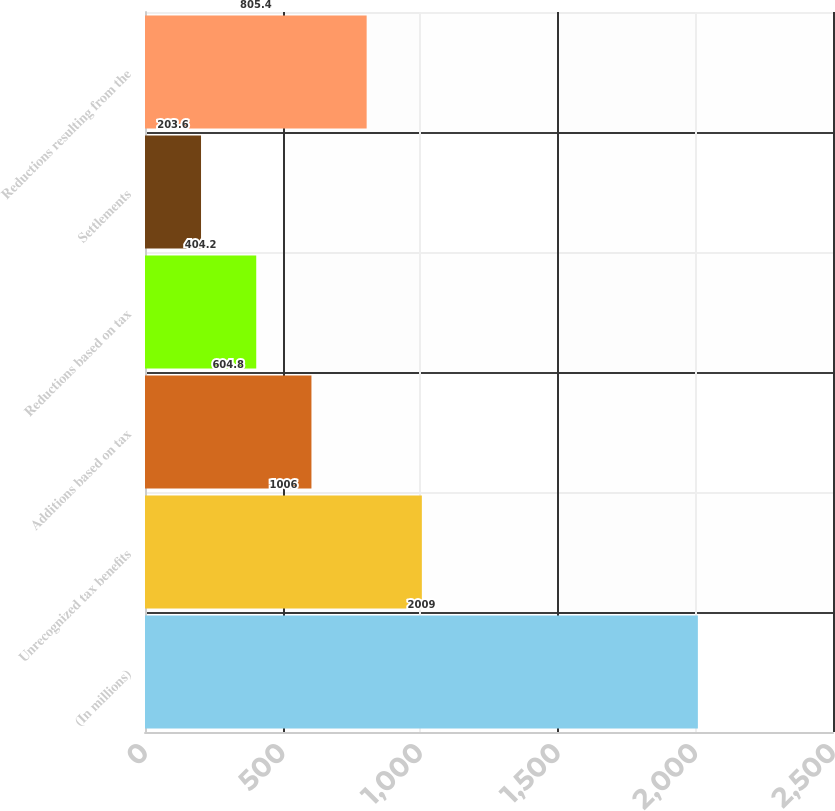Convert chart to OTSL. <chart><loc_0><loc_0><loc_500><loc_500><bar_chart><fcel>(In millions)<fcel>Unrecognized tax benefits<fcel>Additions based on tax<fcel>Reductions based on tax<fcel>Settlements<fcel>Reductions resulting from the<nl><fcel>2009<fcel>1006<fcel>604.8<fcel>404.2<fcel>203.6<fcel>805.4<nl></chart> 